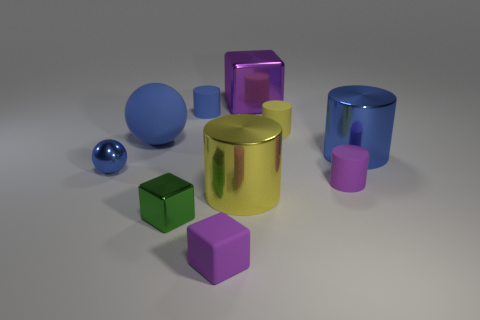Subtract all yellow cylinders. How many purple cubes are left? 2 Subtract all yellow metallic cylinders. How many cylinders are left? 4 Subtract all purple cylinders. How many cylinders are left? 4 Subtract all cyan cylinders. Subtract all green cubes. How many cylinders are left? 5 Subtract all blocks. How many objects are left? 7 Add 5 big yellow things. How many big yellow things are left? 6 Add 4 big red matte cylinders. How many big red matte cylinders exist? 4 Subtract 1 yellow cylinders. How many objects are left? 9 Subtract all small purple rubber cylinders. Subtract all purple rubber cylinders. How many objects are left? 8 